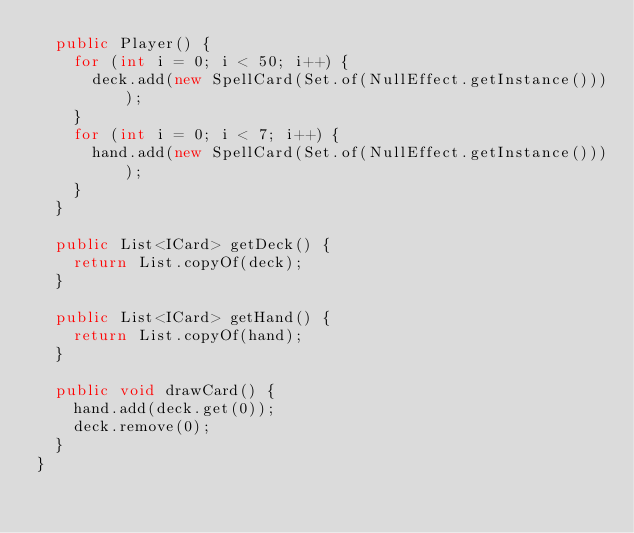<code> <loc_0><loc_0><loc_500><loc_500><_Java_>  public Player() {
    for (int i = 0; i < 50; i++) {
      deck.add(new SpellCard(Set.of(NullEffect.getInstance())));
    }
    for (int i = 0; i < 7; i++) {
      hand.add(new SpellCard(Set.of(NullEffect.getInstance())));
    }
  }

  public List<ICard> getDeck() {
    return List.copyOf(deck);
  }

  public List<ICard> getHand() {
    return List.copyOf(hand);
  }

  public void drawCard() {
    hand.add(deck.get(0));
    deck.remove(0);
  }
}
</code> 